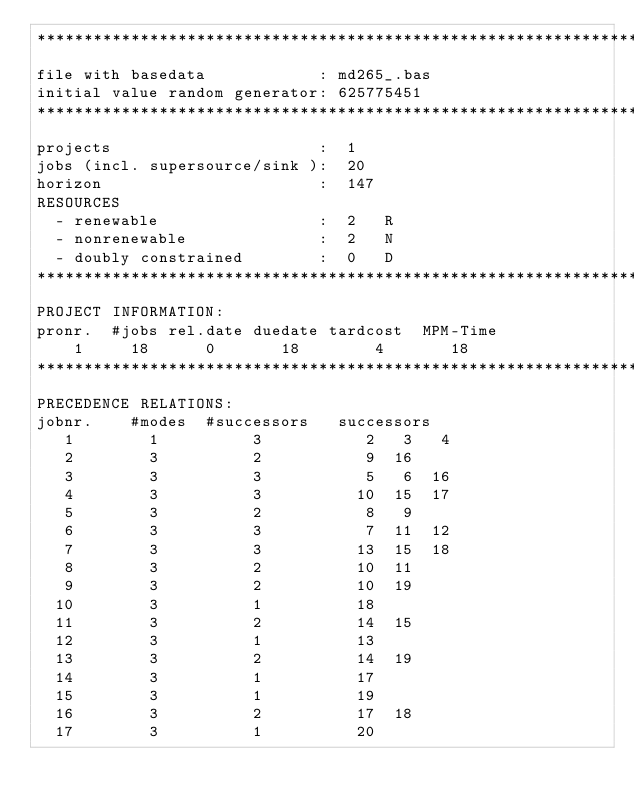Convert code to text. <code><loc_0><loc_0><loc_500><loc_500><_ObjectiveC_>************************************************************************
file with basedata            : md265_.bas
initial value random generator: 625775451
************************************************************************
projects                      :  1
jobs (incl. supersource/sink ):  20
horizon                       :  147
RESOURCES
  - renewable                 :  2   R
  - nonrenewable              :  2   N
  - doubly constrained        :  0   D
************************************************************************
PROJECT INFORMATION:
pronr.  #jobs rel.date duedate tardcost  MPM-Time
    1     18      0       18        4       18
************************************************************************
PRECEDENCE RELATIONS:
jobnr.    #modes  #successors   successors
   1        1          3           2   3   4
   2        3          2           9  16
   3        3          3           5   6  16
   4        3          3          10  15  17
   5        3          2           8   9
   6        3          3           7  11  12
   7        3          3          13  15  18
   8        3          2          10  11
   9        3          2          10  19
  10        3          1          18
  11        3          2          14  15
  12        3          1          13
  13        3          2          14  19
  14        3          1          17
  15        3          1          19
  16        3          2          17  18
  17        3          1          20</code> 